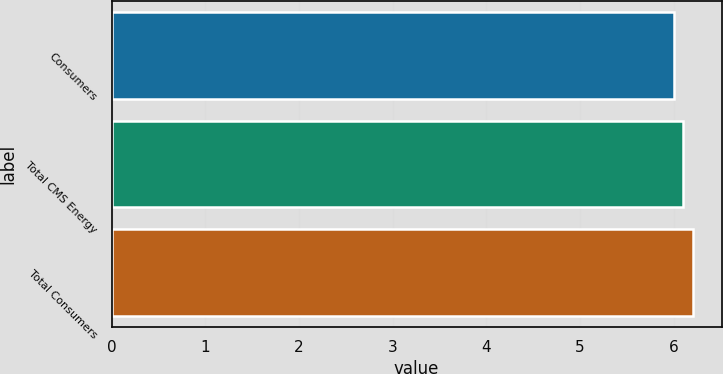Convert chart to OTSL. <chart><loc_0><loc_0><loc_500><loc_500><bar_chart><fcel>Consumers<fcel>Total CMS Energy<fcel>Total Consumers<nl><fcel>6<fcel>6.1<fcel>6.2<nl></chart> 